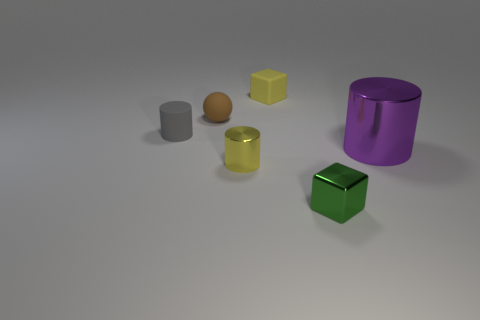Add 3 tiny green matte cylinders. How many objects exist? 9 Subtract all cubes. How many objects are left? 4 Add 1 small gray cylinders. How many small gray cylinders exist? 2 Subtract 1 green cubes. How many objects are left? 5 Subtract all yellow cylinders. Subtract all cubes. How many objects are left? 3 Add 6 tiny gray rubber objects. How many tiny gray rubber objects are left? 7 